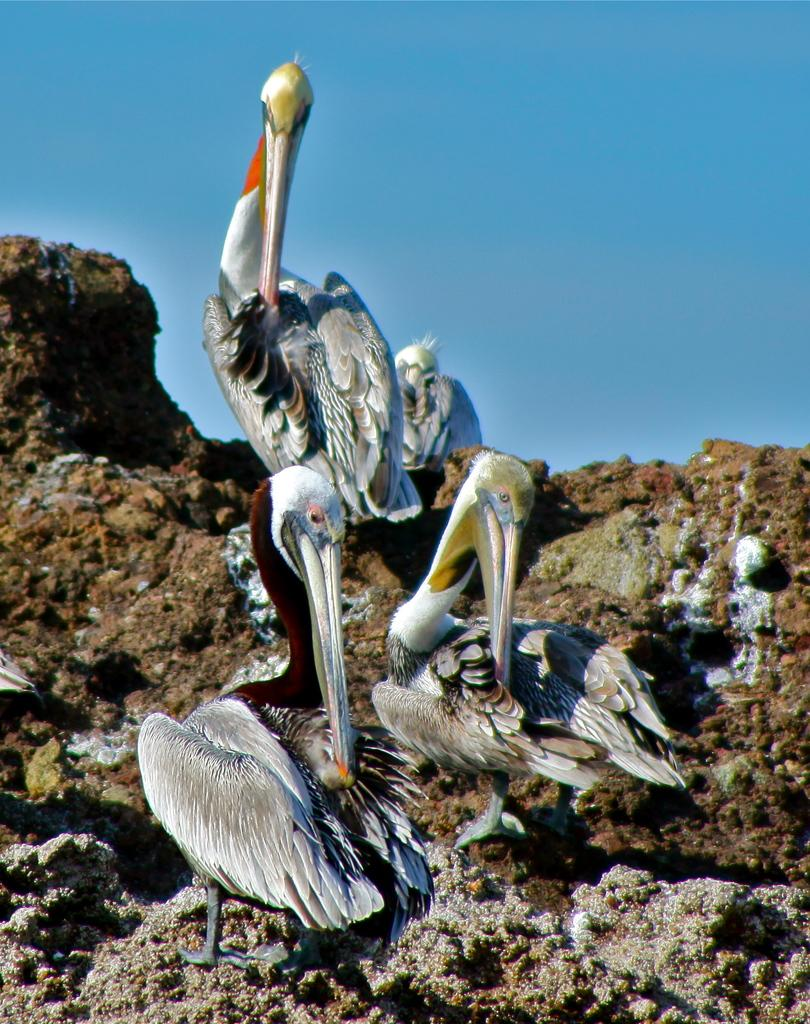How many birds are present in the image? There are four birds in the image. What are the birds standing on? The birds are standing on rocks. What can be seen in the background of the image? The background of the image is the sky. What type of impulse can be seen affecting the birds in the image? There is no impulse present in the image. The image only features four birds standing on rocks with the sky as the background. 